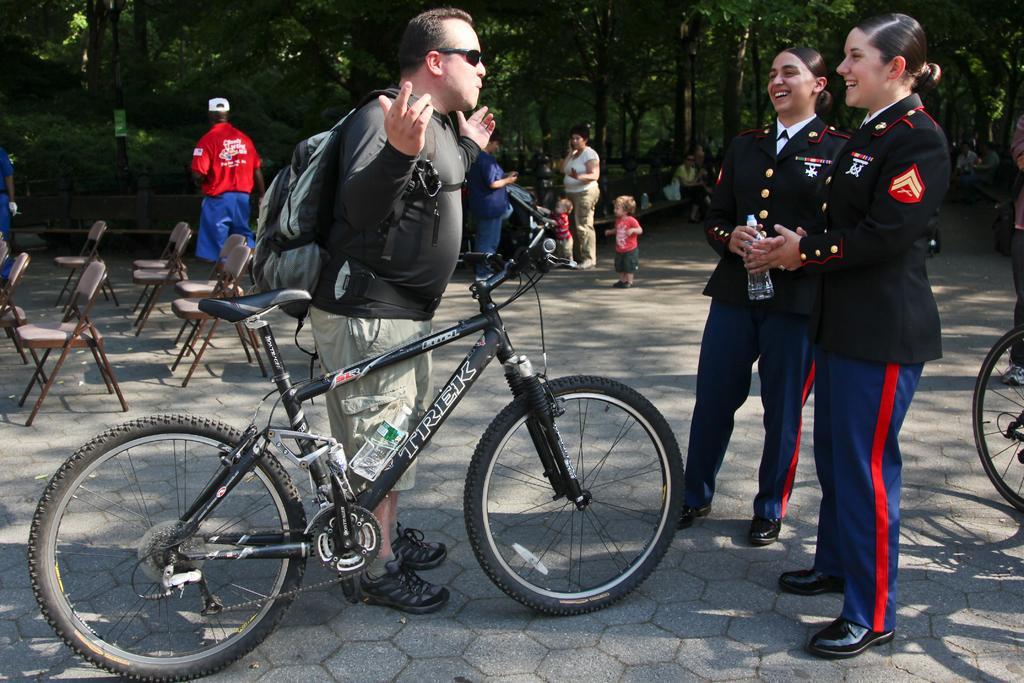Please provide a concise description of this image. There is one man standing and holding a backpack in the middle of this image. There is a bicycle present in front of this image. There are two women standing and wearing black color jacket on the right side of this image. There are some persons standing in the background. There are some chairs on the left side of this image. We can see there are some trees at the top of this image. 